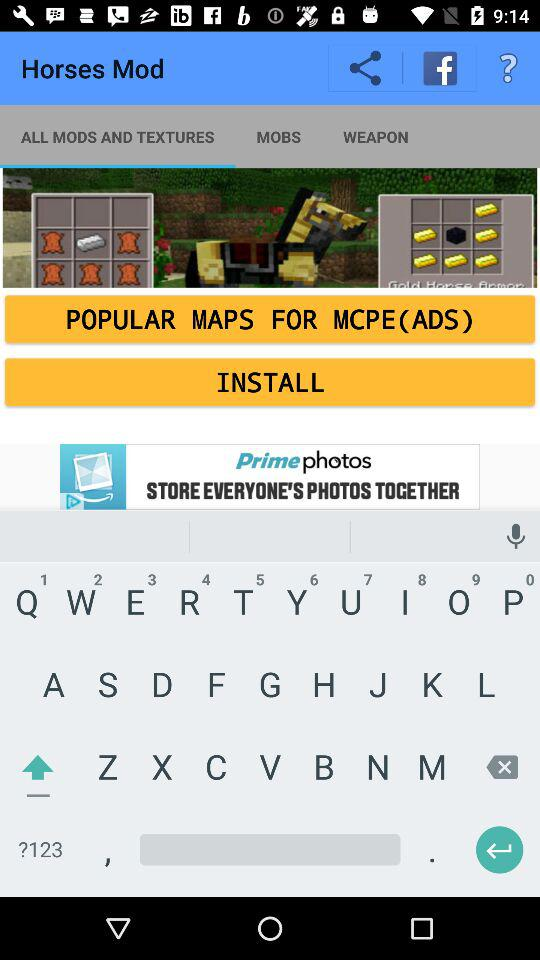Which tab is selected? The selected tab is "WEAPON". 